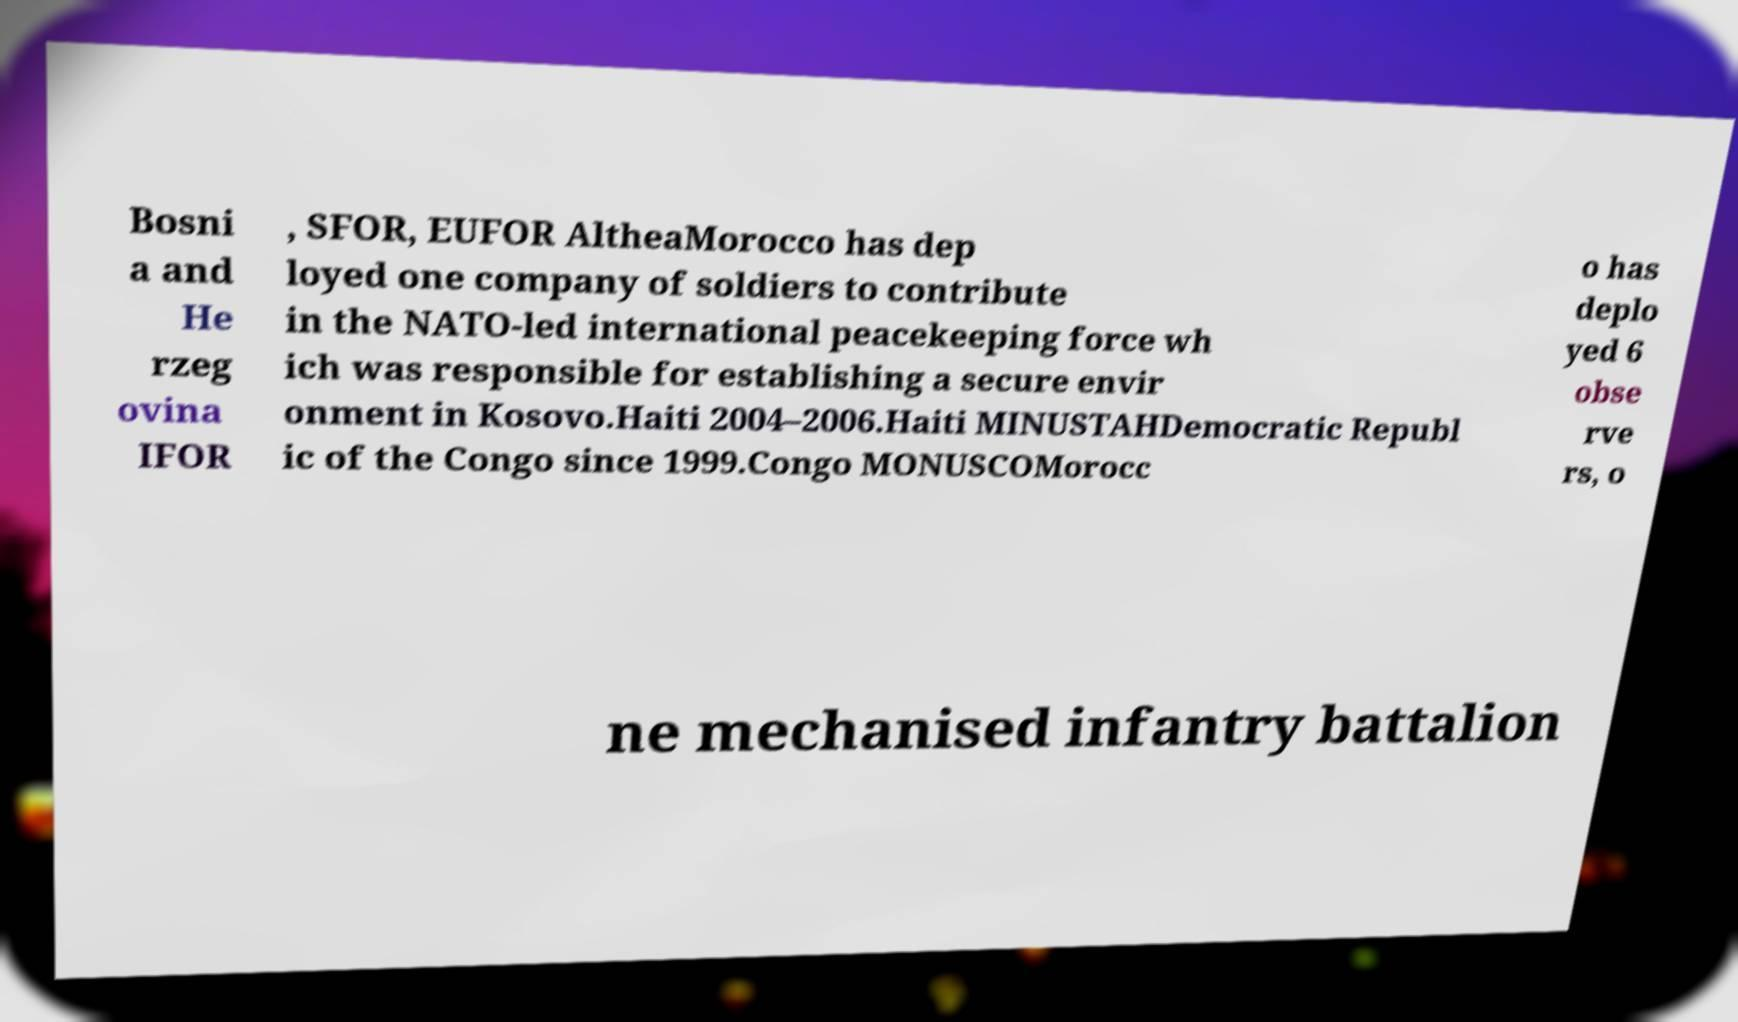What messages or text are displayed in this image? I need them in a readable, typed format. Bosni a and He rzeg ovina IFOR , SFOR, EUFOR AltheaMorocco has dep loyed one company of soldiers to contribute in the NATO-led international peacekeeping force wh ich was responsible for establishing a secure envir onment in Kosovo.Haiti 2004–2006.Haiti MINUSTAHDemocratic Republ ic of the Congo since 1999.Congo MONUSCOMorocc o has deplo yed 6 obse rve rs, o ne mechanised infantry battalion 